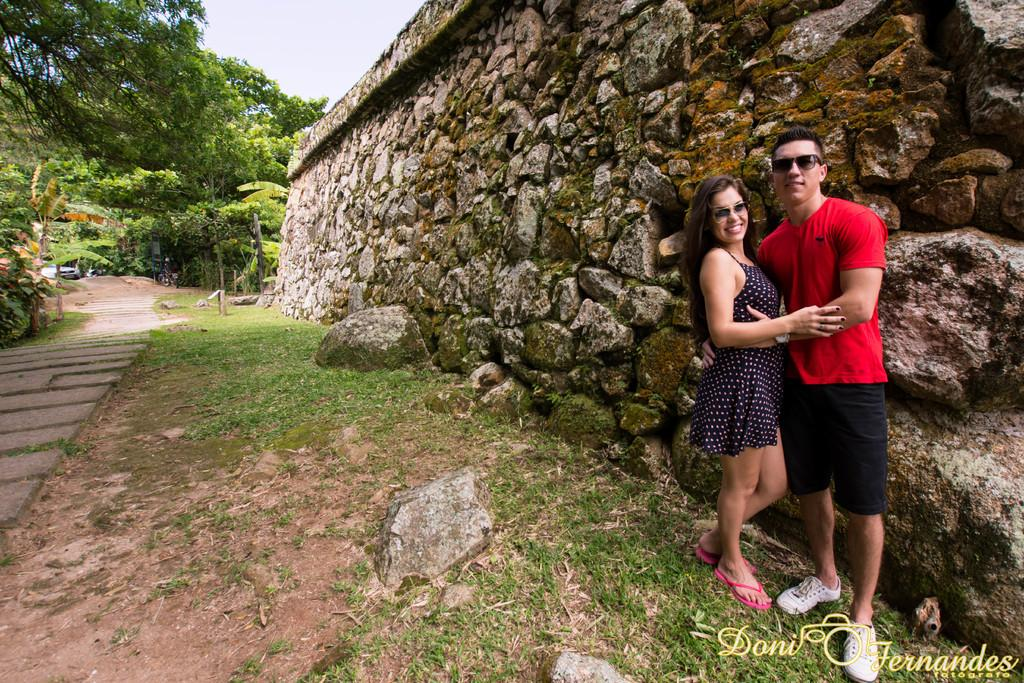Who can be seen standing at the right side of the image? There is a couple standing at the right side of the image. What structure is present in the image? There is a wall in the image. What can be seen at the left side of the image? There is a path at the left side of the image. What type of vegetation is visible in the image? There are green trees in the image. What is visible at the top of the image? The sky is visible at the top of the image. How does the wall balance itself in the image? The wall does not balance itself in the image; it is a stationary structure. Can you tell me how many aunts are present in the image? There is no mention of an aunt in the image; it features a couple standing at the right side. 